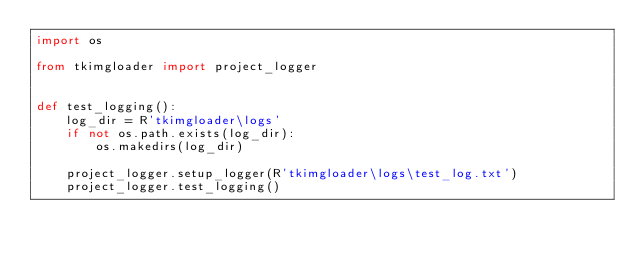<code> <loc_0><loc_0><loc_500><loc_500><_Python_>import os

from tkimgloader import project_logger


def test_logging():
    log_dir = R'tkimgloader\logs'
    if not os.path.exists(log_dir):
        os.makedirs(log_dir)

    project_logger.setup_logger(R'tkimgloader\logs\test_log.txt')
    project_logger.test_logging()
</code> 